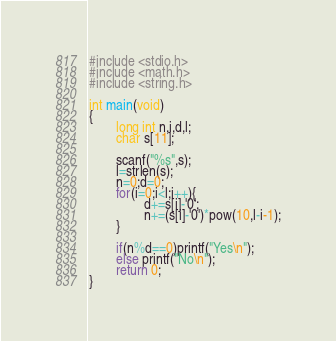<code> <loc_0><loc_0><loc_500><loc_500><_C_>#include <stdio.h>
#include <math.h>
#include <string.h>

int main(void)
{
        long int n,i,d,l;
        char s[11];

        scanf("%s",s);
        l=strlen(s);
        n=0;d=0;
        for(i=0;i<l;i++){
                d+=s[i]-'0';
                n+=(s[i]-'0')*pow(10,l-i-1);
        }

        if(n%d==0)printf("Yes\n");
        else printf("No\n");
        return 0;
}
</code> 